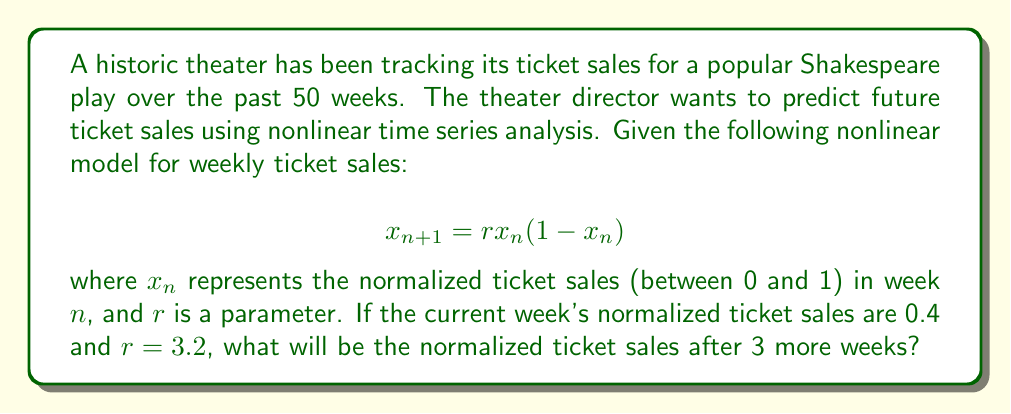Can you answer this question? To solve this problem, we need to iterate the given nonlinear model for three weeks:

1. Start with $x_0 = 0.4$ (current week's normalized ticket sales)

2. Calculate $x_1$ (next week):
   $$x_1 = r \cdot x_0 \cdot (1-x_0) = 3.2 \cdot 0.4 \cdot (1-0.4) = 3.2 \cdot 0.4 \cdot 0.6 = 0.768$$

3. Calculate $x_2$ (two weeks from now):
   $$x_2 = r \cdot x_1 \cdot (1-x_1) = 3.2 \cdot 0.768 \cdot (1-0.768) = 3.2 \cdot 0.768 \cdot 0.232 = 0.570163$$

4. Calculate $x_3$ (three weeks from now):
   $$x_3 = r \cdot x_2 \cdot (1-x_2) = 3.2 \cdot 0.570163 \cdot (1-0.570163) = 3.2 \cdot 0.570163 \cdot 0.429837 = 0.784841$$

Therefore, the normalized ticket sales after 3 weeks will be approximately 0.784841.
Answer: 0.784841 